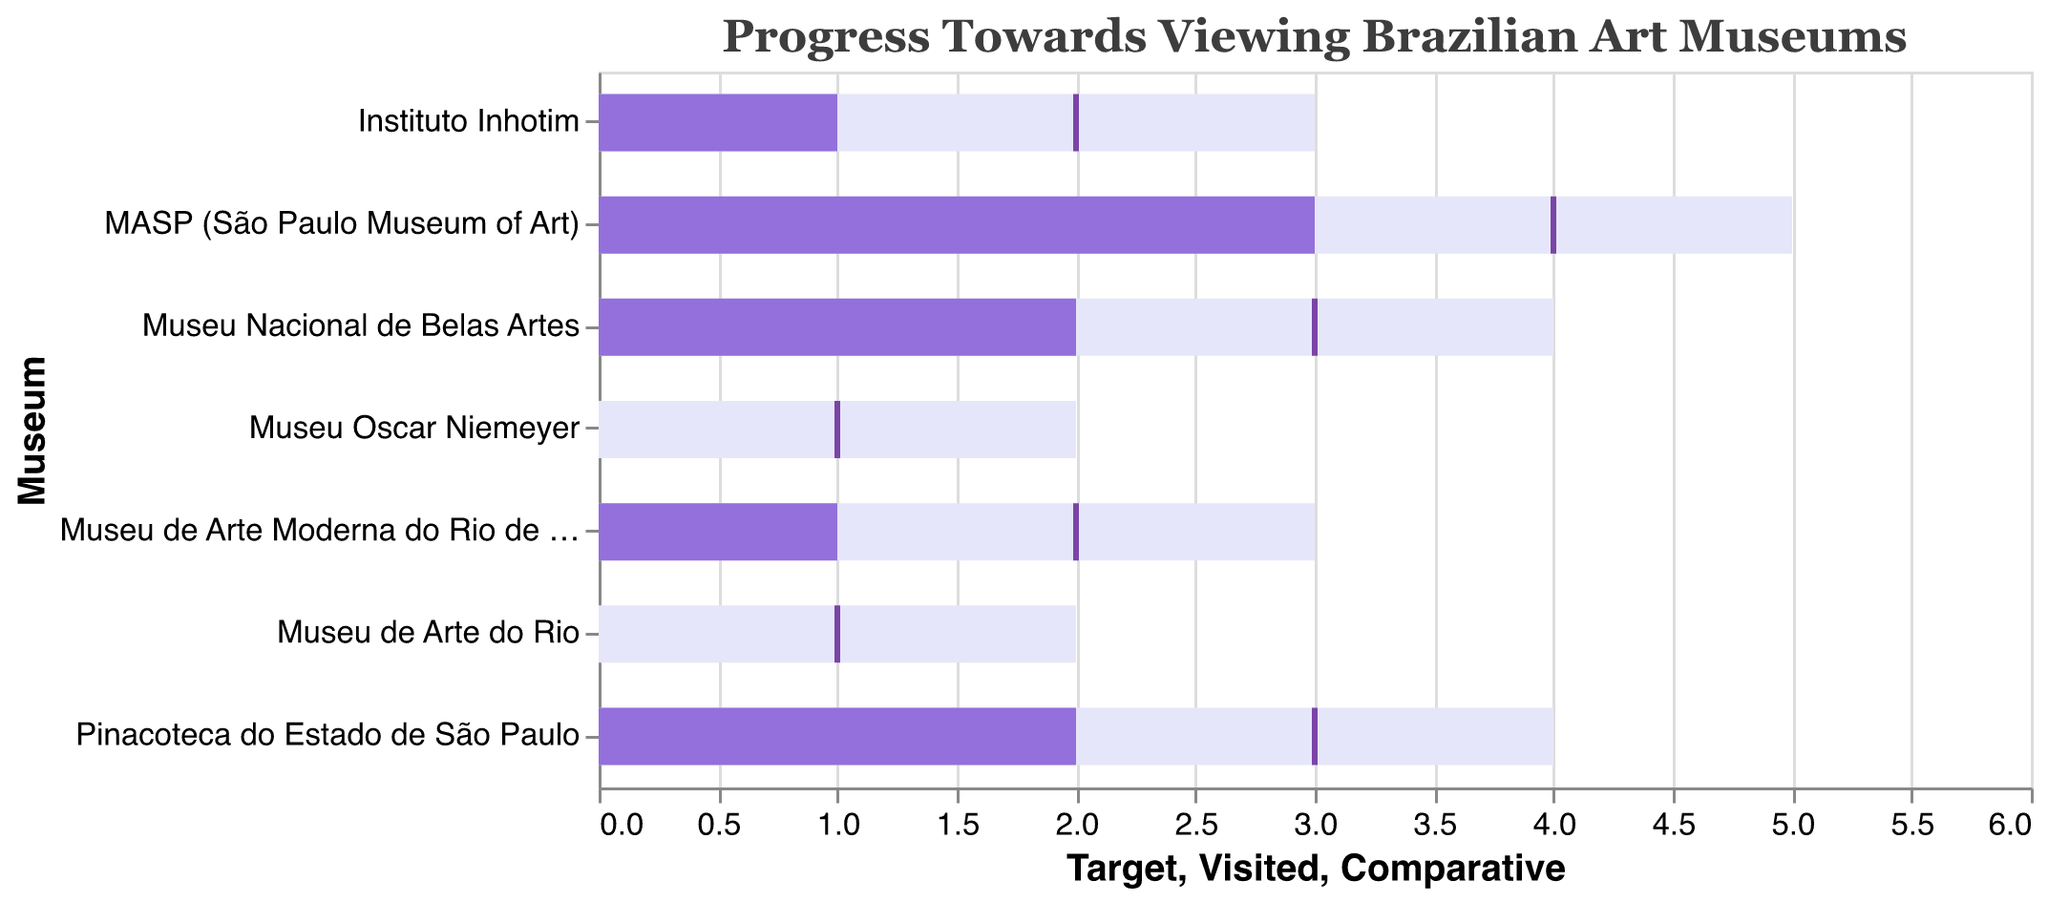What is the title of the chart? The title of the chart is written at the top and is called "Progress Towards Viewing Brazilian Art Museums".
Answer: Progress Towards Viewing Brazilian Art Museums Which museum has the highest target for visits? By looking at the horizontal bar lengths labeled as "Target", the museum with the highest target is the MASP (São Paulo Museum of Art) with a target of 5 visits.
Answer: MASP (São Paulo Museum of Art) Which museum has the least number of visits so far? The museum with the shortest light purple bar, representing the "Visited" field, is either the Museu Oscar Niemeyer or the Museu de Arte do Rio, both having 0 visits.
Answer: Museu Oscar Niemeyer or Museu de Arte do Rio What is the comparative value for the Museu Nacional de Belas Artes? The comparative values are indicated by ticks on the chart. For Museu Nacional de Belas Artes, the tick is located at 3 on the x-axis.
Answer: 3 How many museums have a target of 4 visits? By observing the lengths of the bars representing the "Target" field, we see that two museums, Museu Nacional de Belas Artes and Pinacoteca do Estado de São Paulo, both have a target of 4 visits.
Answer: 2 Which museum has the smallest difference between visited and target visits? To find this, look at the length difference between the light purple "Visited" bar and the lighter bar for "Target". The Museu Oscar Niemeyer and Museu de Arte do Rio both show no difference, as both target and visited are equal to 0 and 2, respectively.
Answer: Museu Oscar Niemeyer and Museu de Arte do Rio What is the combined target for Instituto Inhotim and Museu de Arte Moderna do Rio de Janeiro? The target for Instituto Inhotim is 3, and for Museu de Arte Moderna do Rio de Janeiro, it is also 3. Summing these gives 3 + 3 = 6.
Answer: 6 How many museums have been visited by at least 2 times? Observing the lengths of the "Visited" bars, MASP (3), Museu Nacional de Belas Artes (2), and Pinacoteca do Estado de São Paulo (2) meet this criterion. This sums up to 3 museums.
Answer: 3 Which museum has a comparative value that perfectly matches its "Visited" value? The tick (comparative value) for the Instituto Inhotim aligns perfectly with its "Visited" bar at 1.
Answer: Instituto Inhotim 